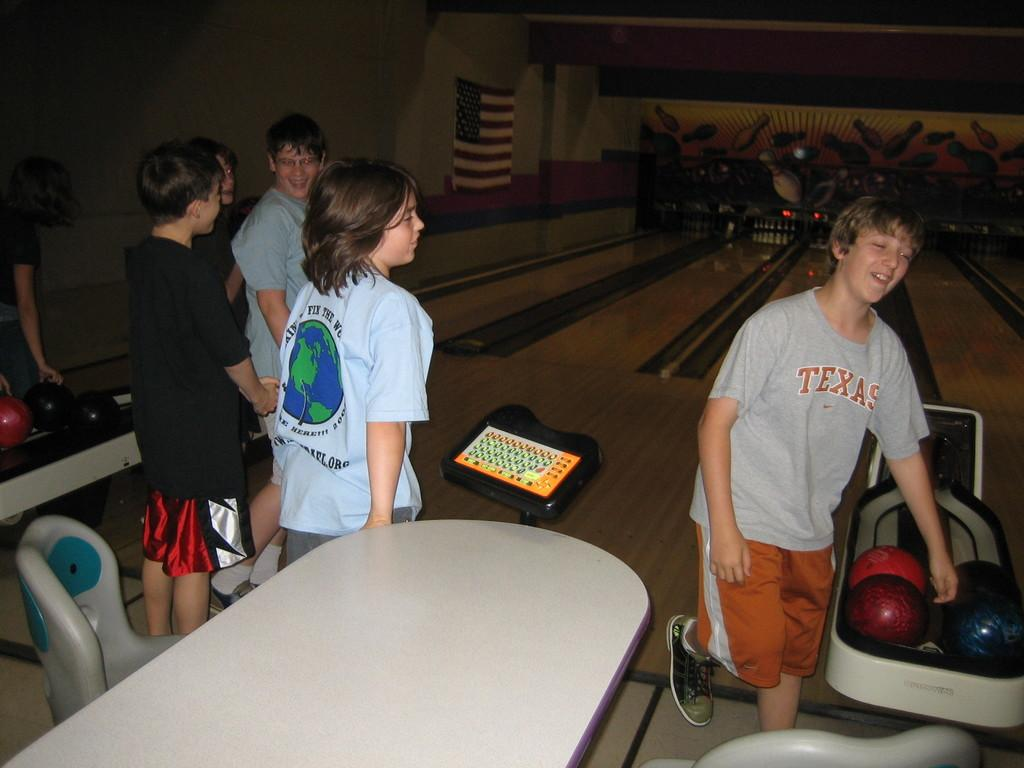What are the people in the image doing? The people in the image are playing a bowling game. What objects are necessary for playing the game? Balls are visible in the image, which are necessary for playing the bowling game. What can be seen in the background of the image? There is a wall in the image. How does the sink contribute to the game in the image? There is no sink present in the image, so it cannot contribute to the game. 